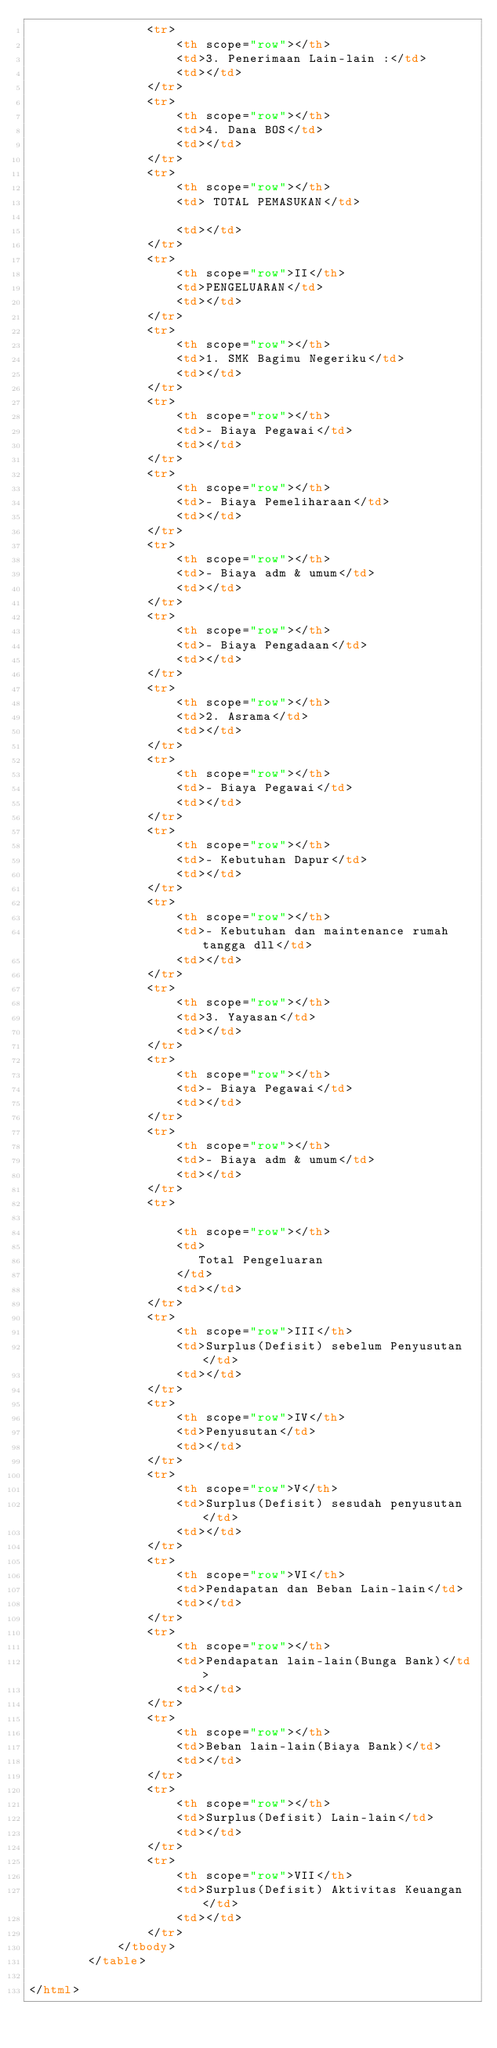Convert code to text. <code><loc_0><loc_0><loc_500><loc_500><_HTML_>                <tr>
                    <th scope="row"></th>
                    <td>3. Penerimaan Lain-lain :</td>
                    <td></td>
                </tr>
                <tr>
                    <th scope="row"></th>
                    <td>4. Dana BOS</td>
                    <td></td>
                </tr>
                <tr>
                    <th scope="row"></th>
                    <td> TOTAL PEMASUKAN</td>
                        
                    <td></td>
                </tr>
                <tr>
                    <th scope="row">II</th>
                    <td>PENGELUARAN</td>
                    <td></td>
                </tr>
                <tr>
                    <th scope="row"></th>
                    <td>1. SMK Bagimu Negeriku</td>
                    <td></td>
                </tr>
                <tr>
                    <th scope="row"></th>
                    <td>- Biaya Pegawai</td>
                    <td></td>
                </tr>
                <tr>
                    <th scope="row"></th>
                    <td>- Biaya Pemeliharaan</td>
                    <td></td>
                </tr>
                <tr>
                    <th scope="row"></th>
                    <td>- Biaya adm & umum</td>
                    <td></td>
                </tr>
                <tr>
                    <th scope="row"></th>
                    <td>- Biaya Pengadaan</td>
                    <td></td>
                </tr>
                <tr>
                    <th scope="row"></th>
                    <td>2. Asrama</td>
                    <td></td>
                </tr>
                <tr>
                    <th scope="row"></th>
                    <td>- Biaya Pegawai</td>
                    <td></td>
                </tr>
                <tr>
                    <th scope="row"></th>
                    <td>- Kebutuhan Dapur</td>
                    <td></td>
                </tr>
                <tr>
                    <th scope="row"></th>
                    <td>- Kebutuhan dan maintenance rumah tangga dll</td>
                    <td></td>
                </tr>
                <tr>
                    <th scope="row"></th>
                    <td>3. Yayasan</td>
                    <td></td>
                </tr>
                <tr>
                    <th scope="row"></th>
                    <td>- Biaya Pegawai</td>
                    <td></td>
                </tr>
                <tr>
                    <th scope="row"></th>
                    <td>- Biaya adm & umum</td>
                    <td></td>
                </tr>
                <tr>

                    <th scope="row"></th>
                    <td>
                       Total Pengeluaran
                    </td>
                    <td></td>
                </tr>
                <tr>
                    <th scope="row">III</th>
                    <td>Surplus(Defisit) sebelum Penyusutan</td>
                    <td></td>
                </tr>
                <tr>
                    <th scope="row">IV</th>
                    <td>Penyusutan</td>
                    <td></td>
                </tr>
                <tr>
                    <th scope="row">V</th>
                    <td>Surplus(Defisit) sesudah penyusutan</td>
                    <td></td>
                </tr>
                <tr>
                    <th scope="row">VI</th>
                    <td>Pendapatan dan Beban Lain-lain</td>
                    <td></td>
                </tr>
                <tr>
                    <th scope="row"></th>
                    <td>Pendapatan lain-lain(Bunga Bank)</td>
                    <td></td>
                </tr>
                <tr>
                    <th scope="row"></th>
                    <td>Beban lain-lain(Biaya Bank)</td>
                    <td></td>
                </tr>
                <tr>
                    <th scope="row"></th>
                    <td>Surplus(Defisit) Lain-lain</td>
                    <td></td>
                </tr>
                <tr>
                    <th scope="row">VII</th>
                    <td>Surplus(Defisit) Aktivitas Keuangan</td>
                    <td></td>
                </tr>
            </tbody>
        </table>

</html></code> 